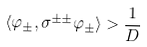Convert formula to latex. <formula><loc_0><loc_0><loc_500><loc_500>\langle \varphi _ { \pm } , \sigma ^ { \pm \pm } \varphi _ { \pm } \rangle > \frac { 1 } { D }</formula> 